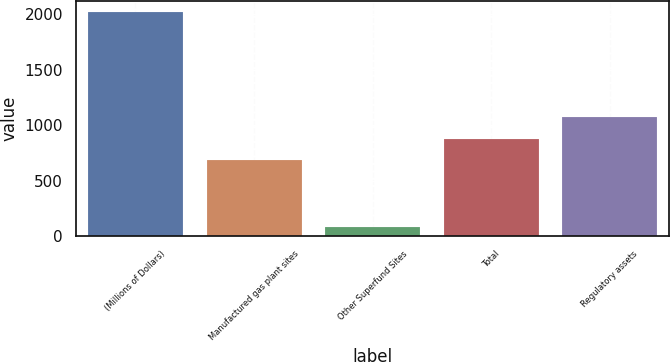Convert chart to OTSL. <chart><loc_0><loc_0><loc_500><loc_500><bar_chart><fcel>(Millions of Dollars)<fcel>Manufactured gas plant sites<fcel>Other Superfund Sites<fcel>Total<fcel>Regulatory assets<nl><fcel>2014<fcel>684<fcel>80<fcel>877.4<fcel>1070.8<nl></chart> 